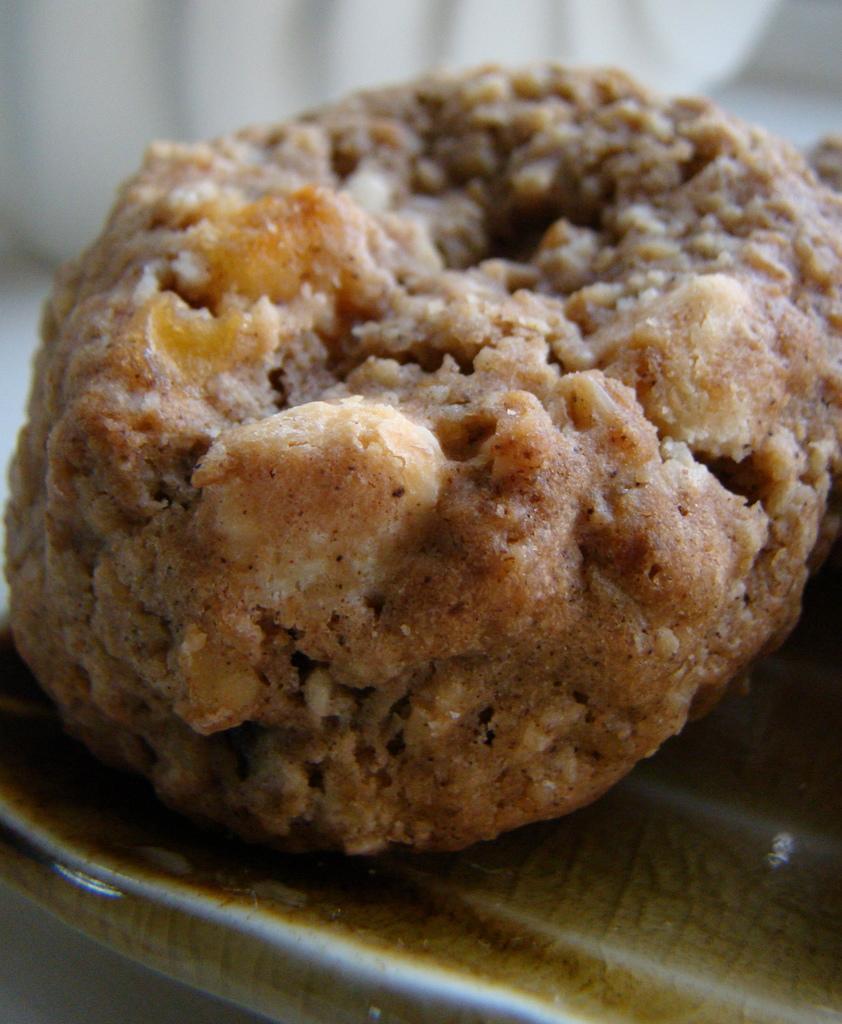Can you describe this image briefly? In this image we can food item on the plate, and the background is blurred. 